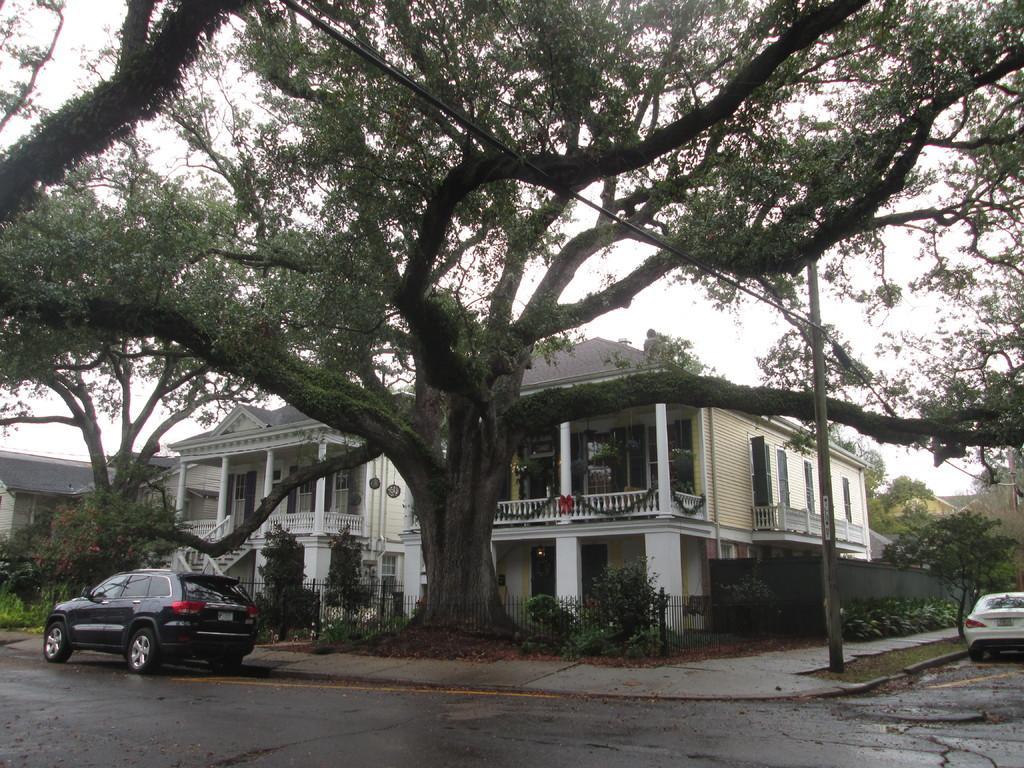Describe this image in one or two sentences. In this image I can see few buildings, windows, stairs, few trees, vehicles, fencing and a pole. The sky is in white color. 